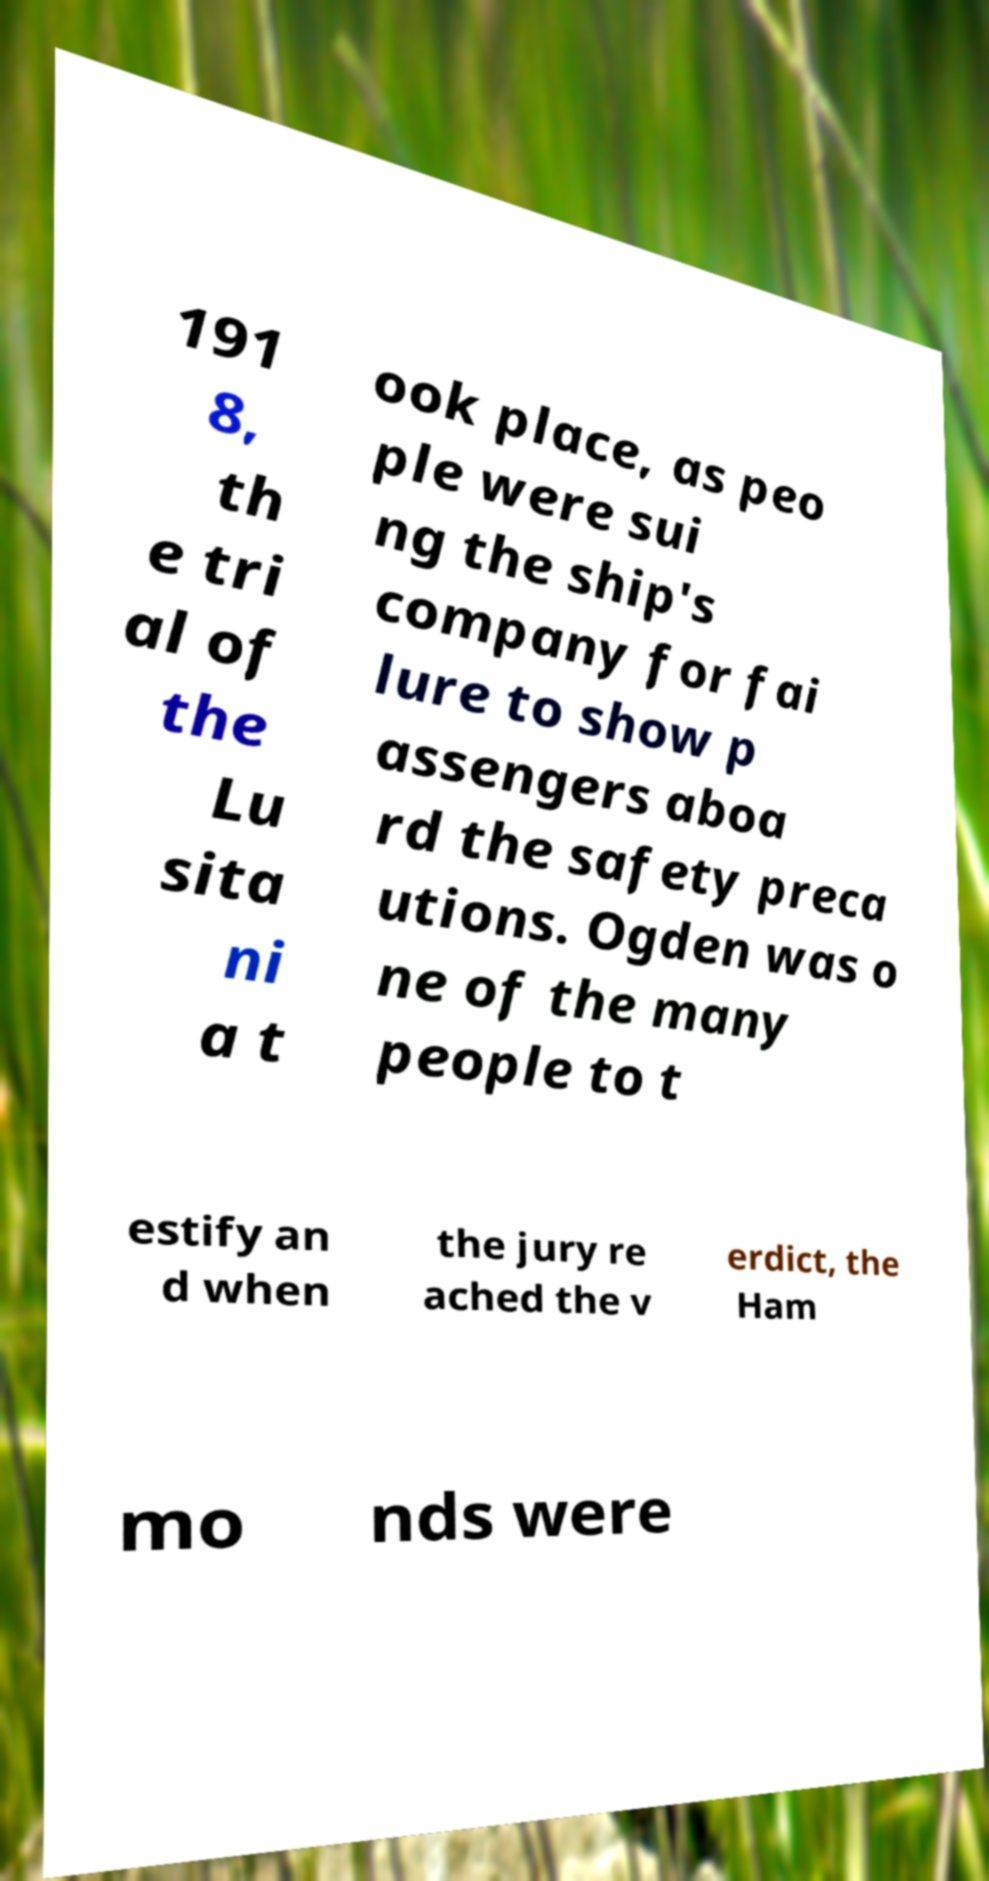For documentation purposes, I need the text within this image transcribed. Could you provide that? 191 8, th e tri al of the Lu sita ni a t ook place, as peo ple were sui ng the ship's company for fai lure to show p assengers aboa rd the safety preca utions. Ogden was o ne of the many people to t estify an d when the jury re ached the v erdict, the Ham mo nds were 